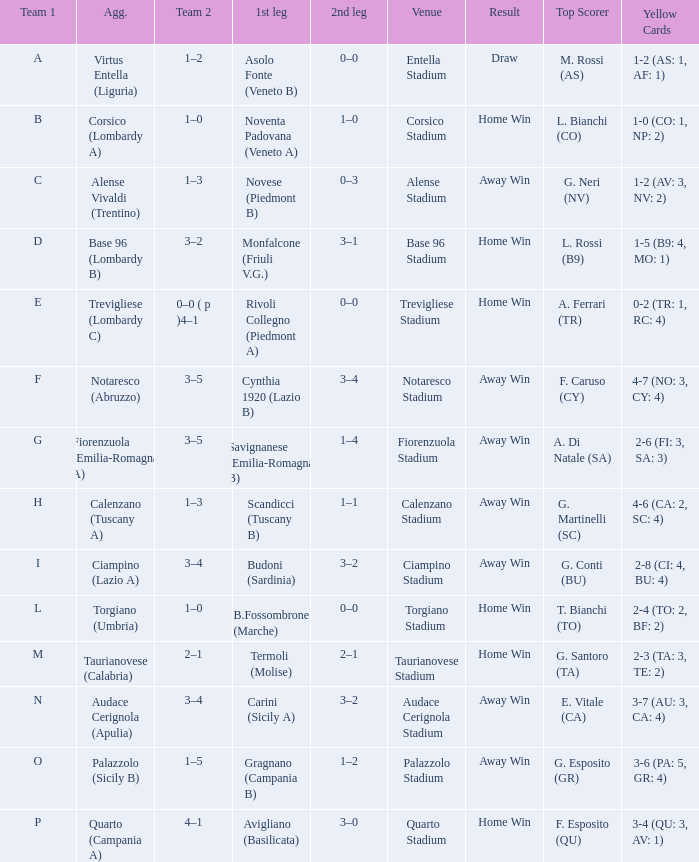What 1st leg has Alense Vivaldi (Trentino) as Agg.? Novese (Piedmont B). 